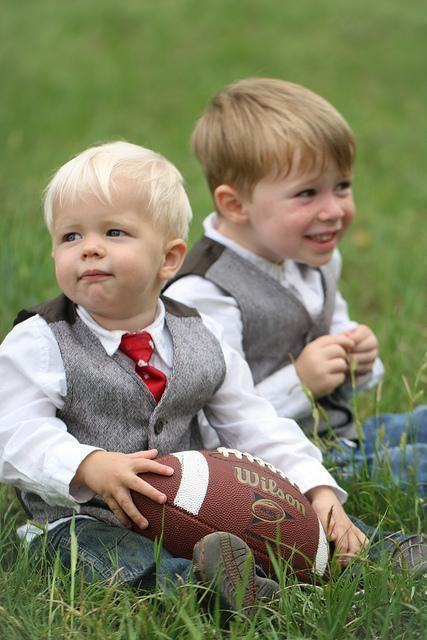What British sport could this ball be used for?
From the following set of four choices, select the accurate answer to respond to the question.
Options: Rugby, soccer, bowls, golf. Rugby. 